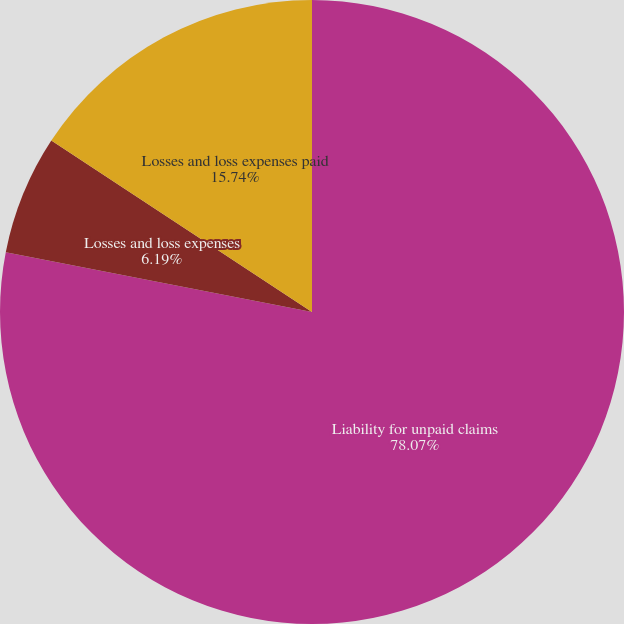Convert chart. <chart><loc_0><loc_0><loc_500><loc_500><pie_chart><fcel>Liability for unpaid claims<fcel>Losses and loss expenses<fcel>Losses and loss expenses paid<nl><fcel>78.07%<fcel>6.19%<fcel>15.74%<nl></chart> 